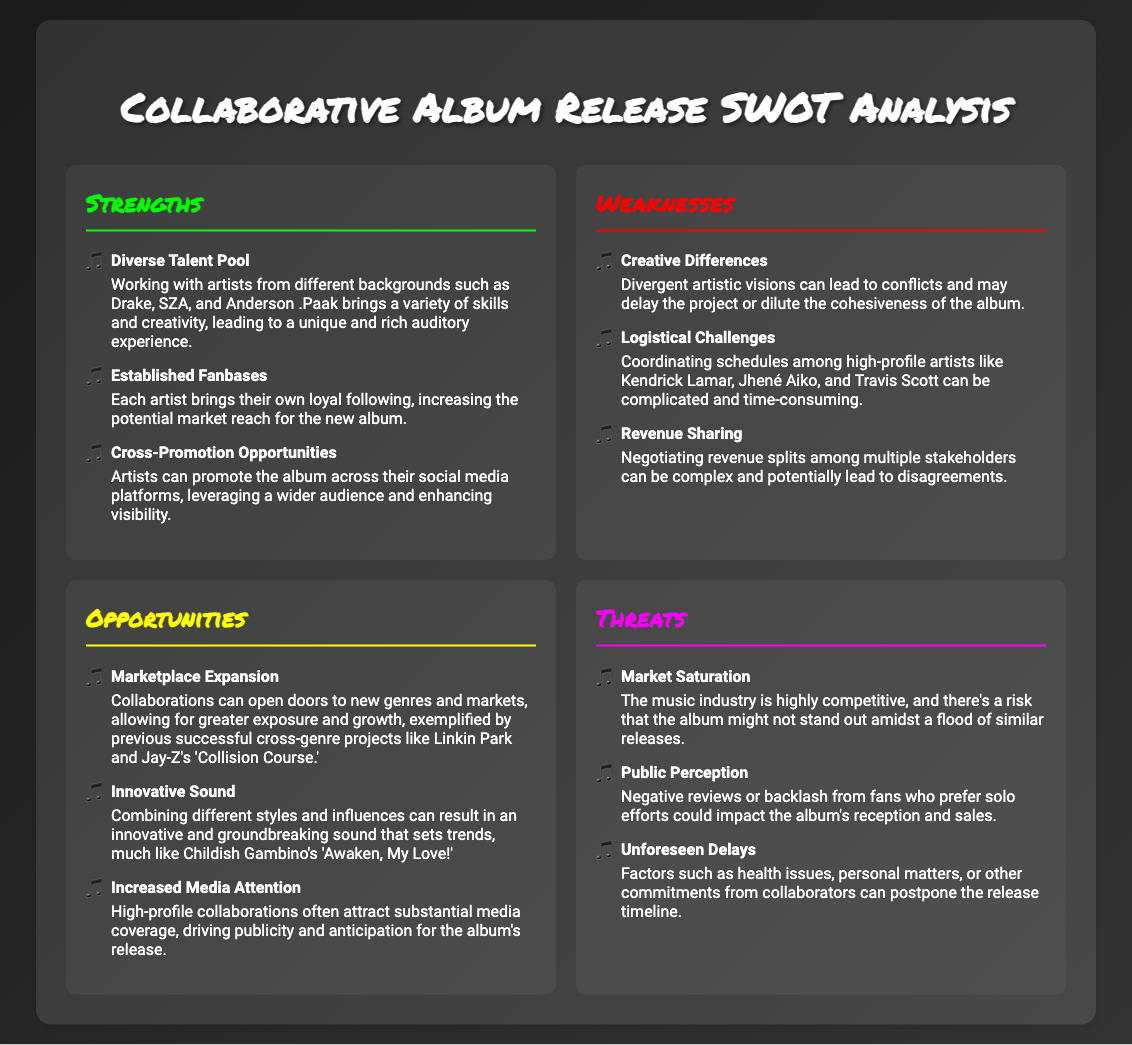What is one of the strengths of collaborating on this album? The strengths section lists several advantages, one of which is the diverse talent pool that can enrich the album's sound.
Answer: Diverse Talent Pool Who are two artists mentioned in the weaknesses section? The weaknesses section highlights challenges faced, mentioning artists like Kendrick Lamar and Jhené Aiko as examples of high-profile collaborators.
Answer: Kendrick Lamar, Jhené Aiko What opportunity is related to genre expansion? The opportunities section talks about marketplace expansion, noting that collaborations can open doors to new genres and markets.
Answer: Marketplace Expansion What color represents the threats section? The colors used for each section provide a visual way to distinguish them, with the threats section represented in magenta.
Answer: Magenta How many weaknesses are listed in the document? By counting the entries in the weaknesses section, we find there are three listed weaknesses.
Answer: Three What innovative sound example is mentioned for collaboration success? The opportunities section emphasizes how combining different styles can result in a groundbreaking sound, referencing Childish Gambino's 'Awaken, My Love!'
Answer: 'Awaken, My Love!' What potential risk does market saturation present? The threats section explains that market saturation can prevent the album from standing out in a competitive industry.
Answer: Not stand out What aspect does increased media attention relate to in the opportunities? The opportunities section notes that high-profile collaborations attract substantial media coverage, which ultimately drives anticipation for the album.
Answer: Media coverage 